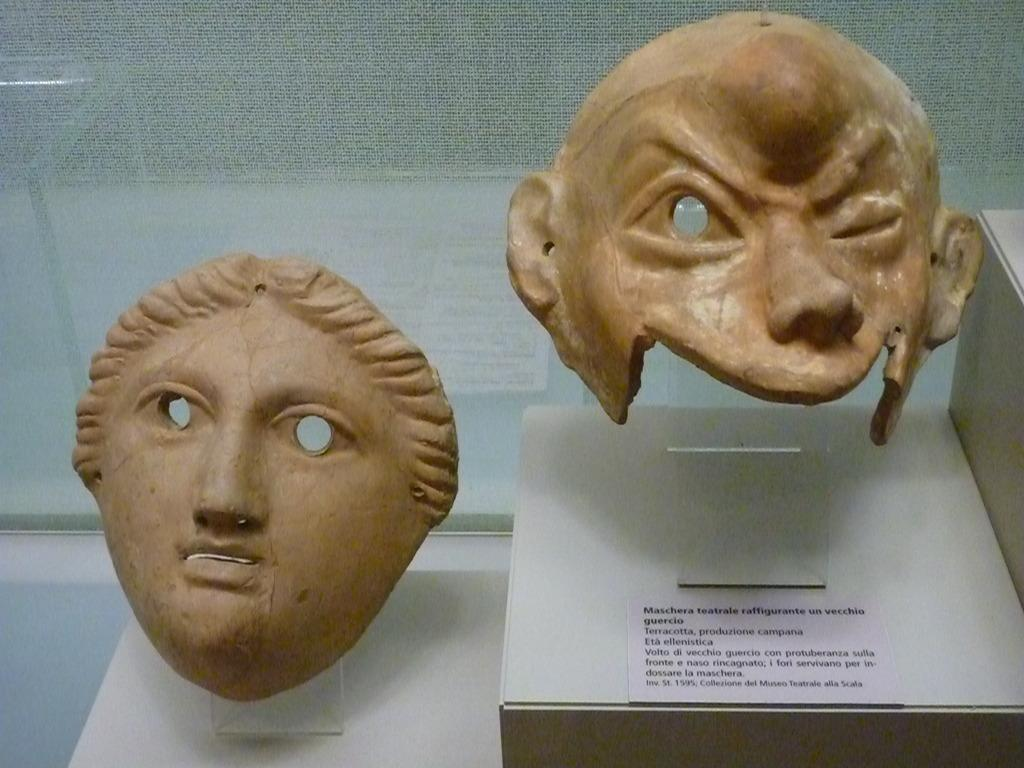What objects are in the front of the image? There are masks in the front of the image. What is the location of the text in the image? The text is written on a paper, and the paper is on the right side of the image. What type of tin can be seen playing music in the image? There is no tin or music present in the image; it features masks and text on a paper. How is the string used in the image? There is no string present in the image. 